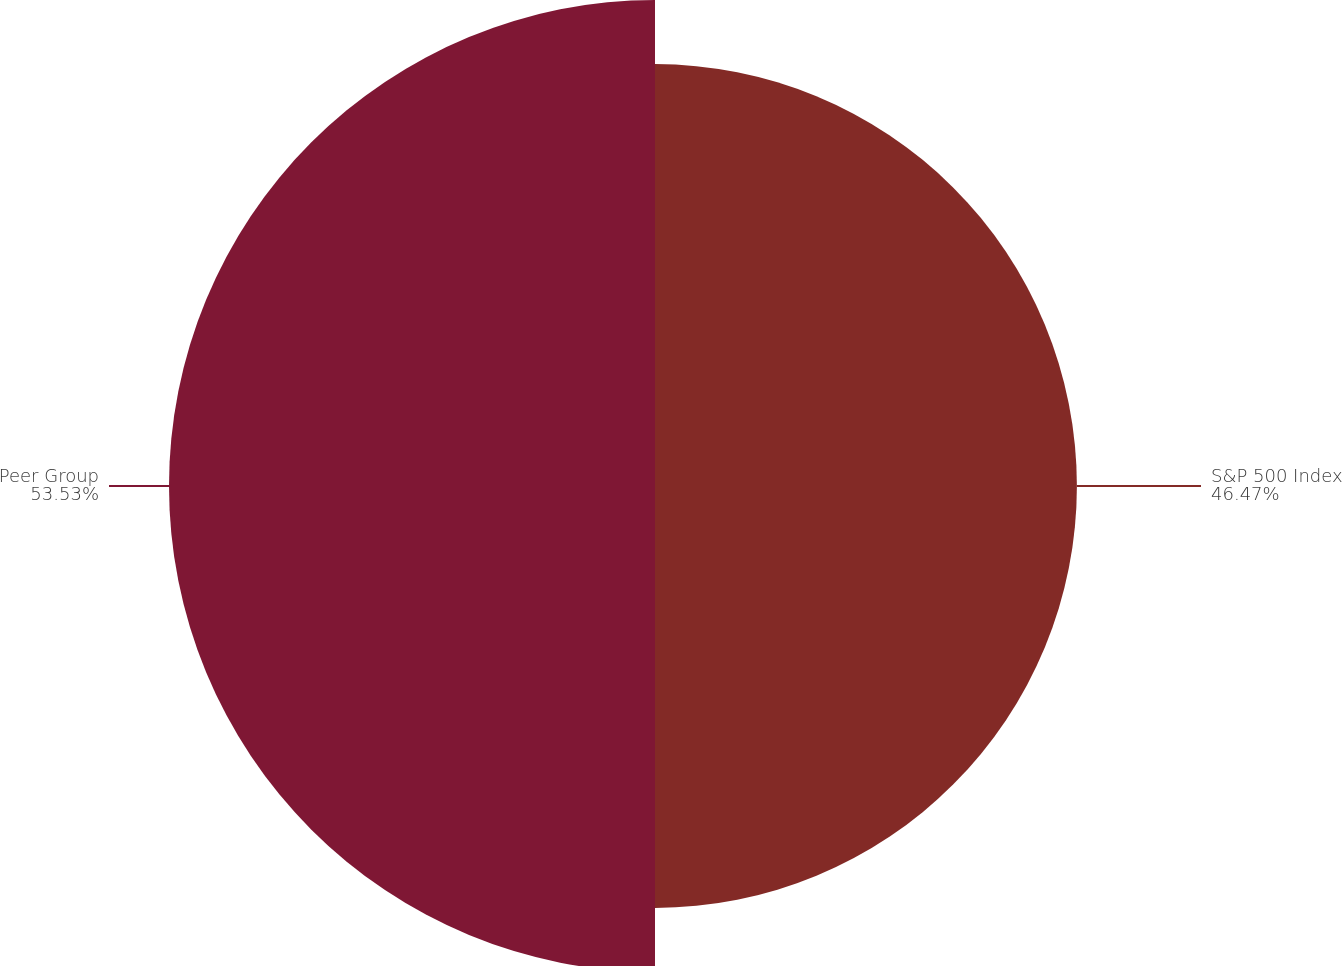Convert chart to OTSL. <chart><loc_0><loc_0><loc_500><loc_500><pie_chart><fcel>S&P 500 Index<fcel>Peer Group<nl><fcel>46.47%<fcel>53.53%<nl></chart> 